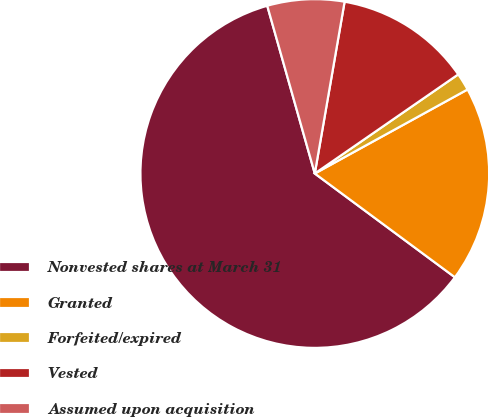<chart> <loc_0><loc_0><loc_500><loc_500><pie_chart><fcel>Nonvested shares at March 31<fcel>Granted<fcel>Forfeited/expired<fcel>Vested<fcel>Assumed upon acquisition<nl><fcel>60.46%<fcel>18.15%<fcel>1.62%<fcel>12.64%<fcel>7.13%<nl></chart> 